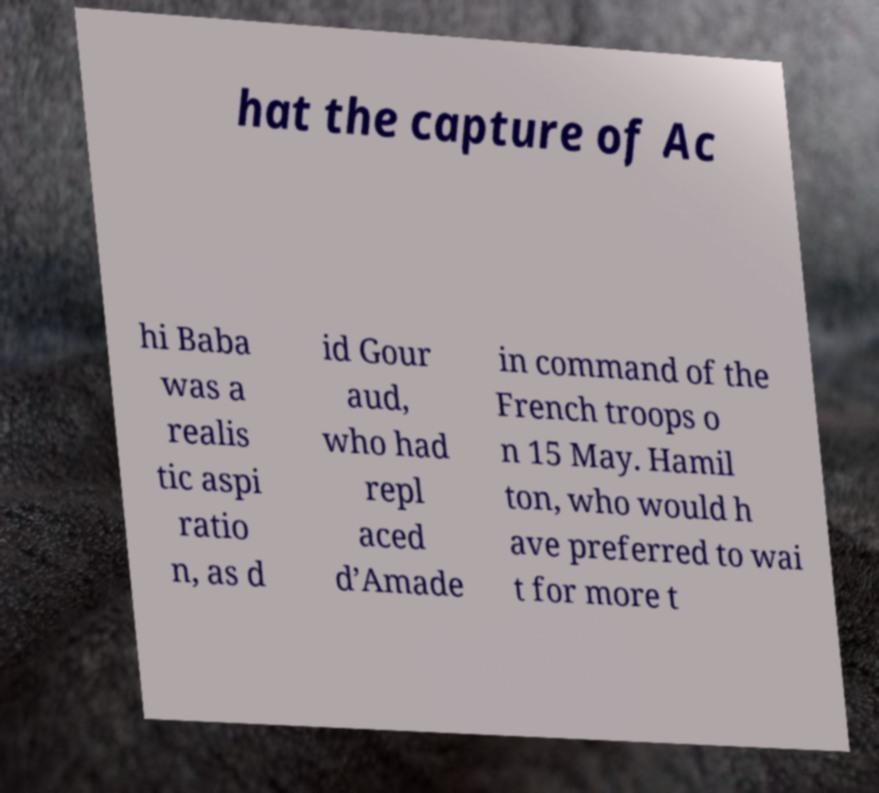There's text embedded in this image that I need extracted. Can you transcribe it verbatim? hat the capture of Ac hi Baba was a realis tic aspi ratio n, as d id Gour aud, who had repl aced d’Amade in command of the French troops o n 15 May. Hamil ton, who would h ave preferred to wai t for more t 